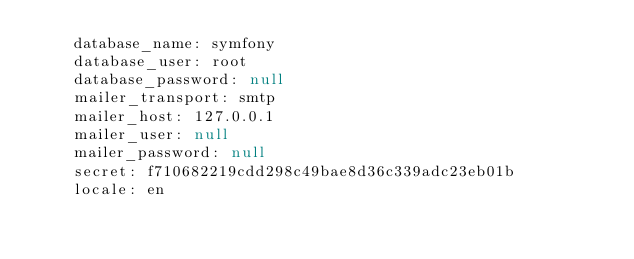<code> <loc_0><loc_0><loc_500><loc_500><_YAML_>    database_name: symfony
    database_user: root
    database_password: null
    mailer_transport: smtp
    mailer_host: 127.0.0.1
    mailer_user: null
    mailer_password: null
    secret: f710682219cdd298c49bae8d36c339adc23eb01b
    locale: en
</code> 